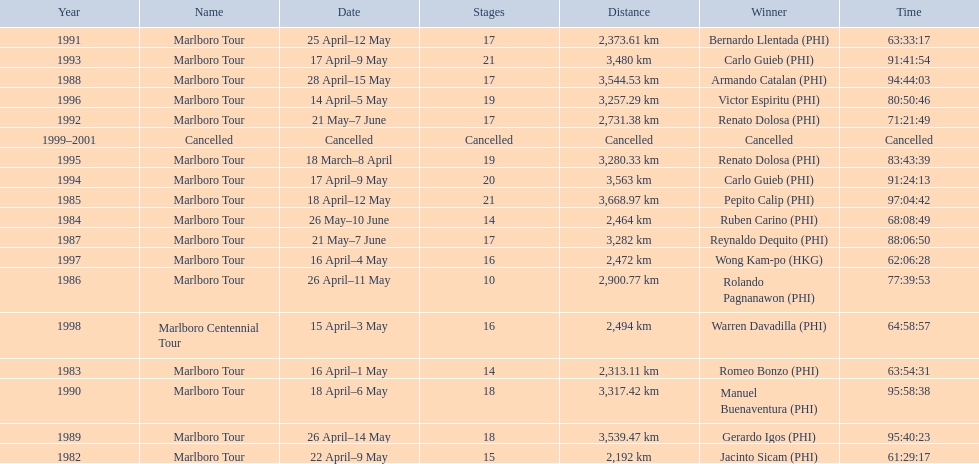How long did it take warren davadilla to complete the 1998 marlboro centennial tour? 64:58:57. 